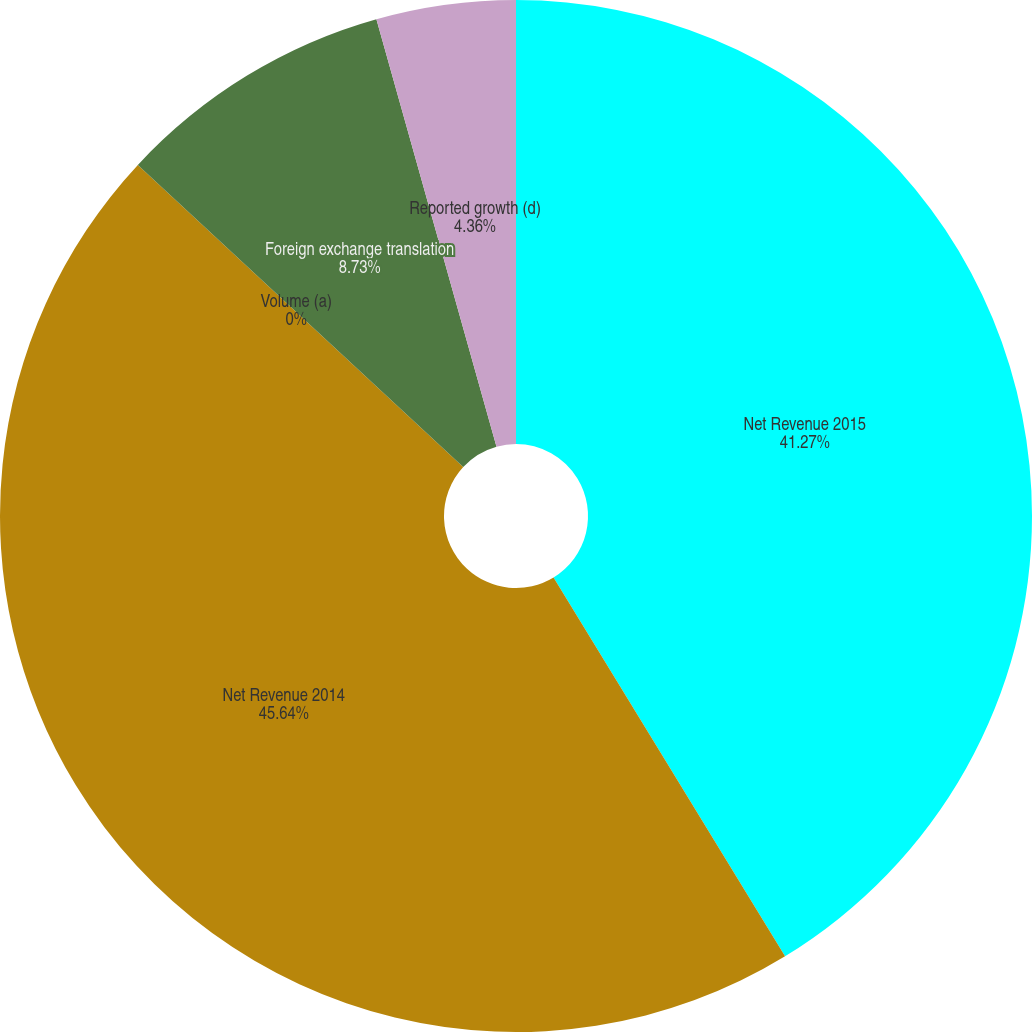Convert chart. <chart><loc_0><loc_0><loc_500><loc_500><pie_chart><fcel>Net Revenue 2015<fcel>Net Revenue 2014<fcel>Volume (a)<fcel>Foreign exchange translation<fcel>Reported growth (d)<nl><fcel>41.27%<fcel>45.64%<fcel>0.0%<fcel>8.73%<fcel>4.36%<nl></chart> 